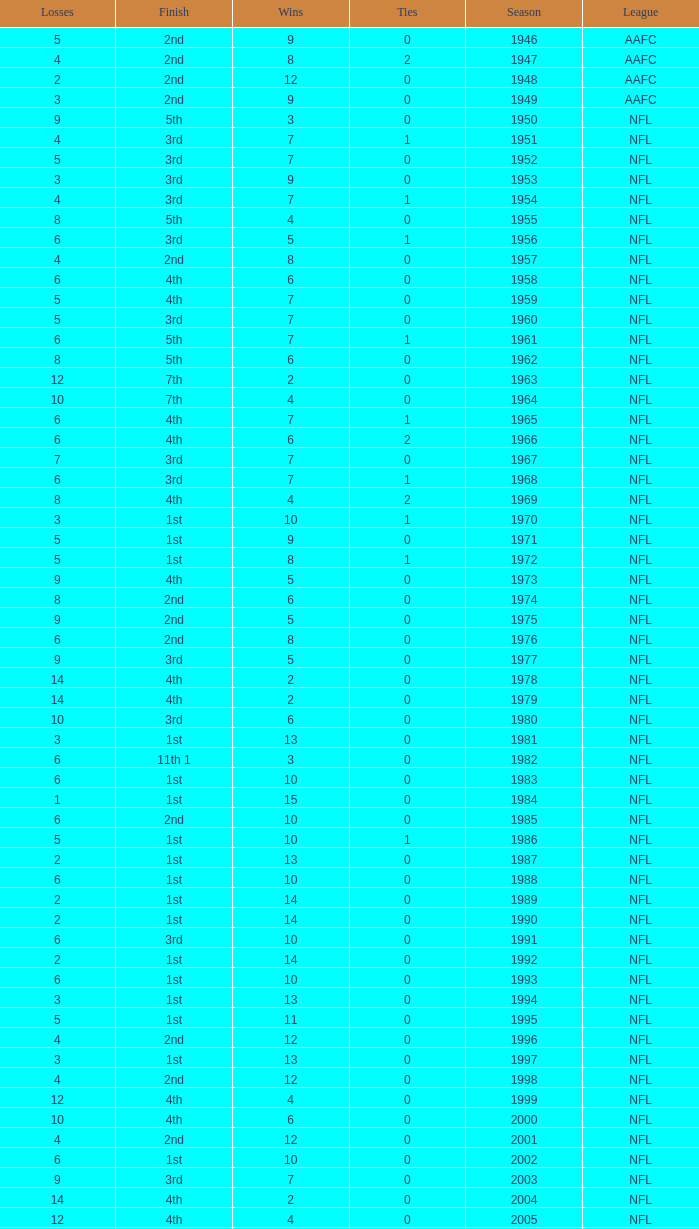What is the lowest number of ties in the NFL, with less than 2 losses and less than 15 wins? None. 